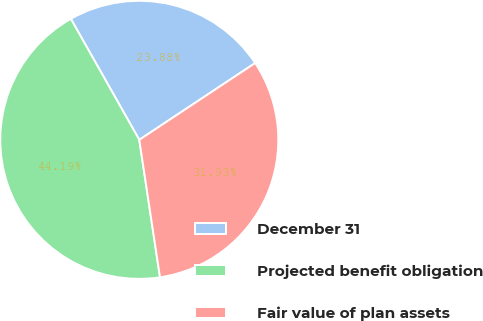Convert chart to OTSL. <chart><loc_0><loc_0><loc_500><loc_500><pie_chart><fcel>December 31<fcel>Projected benefit obligation<fcel>Fair value of plan assets<nl><fcel>23.88%<fcel>44.19%<fcel>31.93%<nl></chart> 